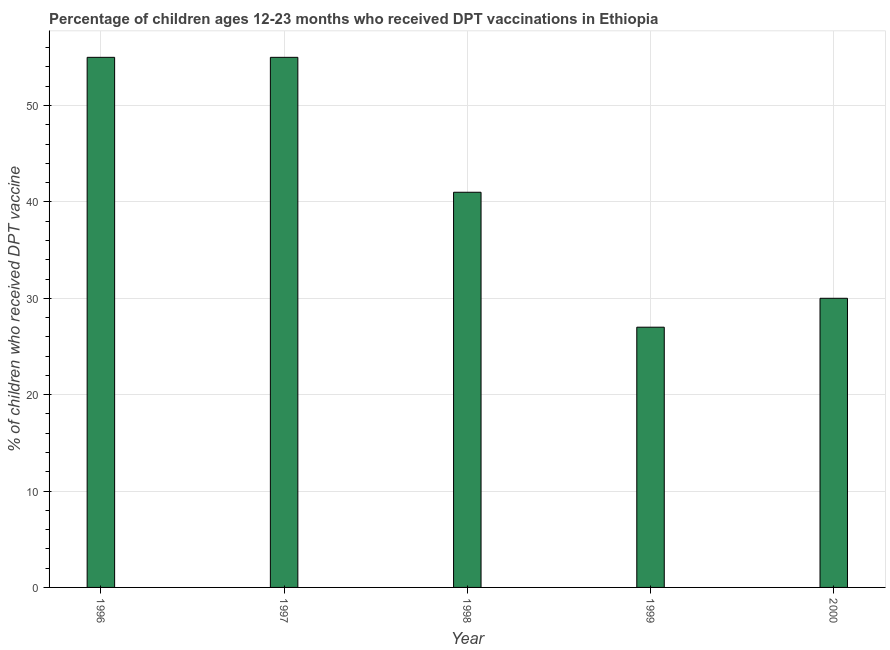Does the graph contain grids?
Keep it short and to the point. Yes. What is the title of the graph?
Provide a short and direct response. Percentage of children ages 12-23 months who received DPT vaccinations in Ethiopia. What is the label or title of the X-axis?
Give a very brief answer. Year. What is the label or title of the Y-axis?
Offer a terse response. % of children who received DPT vaccine. What is the percentage of children who received dpt vaccine in 1996?
Provide a short and direct response. 55. In which year was the percentage of children who received dpt vaccine maximum?
Offer a terse response. 1996. What is the sum of the percentage of children who received dpt vaccine?
Your answer should be very brief. 208. What is the average percentage of children who received dpt vaccine per year?
Keep it short and to the point. 41. What is the median percentage of children who received dpt vaccine?
Make the answer very short. 41. What is the ratio of the percentage of children who received dpt vaccine in 1998 to that in 2000?
Your response must be concise. 1.37. Is the percentage of children who received dpt vaccine in 1998 less than that in 1999?
Your answer should be compact. No. Is the sum of the percentage of children who received dpt vaccine in 1998 and 1999 greater than the maximum percentage of children who received dpt vaccine across all years?
Ensure brevity in your answer.  Yes. What is the difference between the highest and the lowest percentage of children who received dpt vaccine?
Your answer should be very brief. 28. In how many years, is the percentage of children who received dpt vaccine greater than the average percentage of children who received dpt vaccine taken over all years?
Keep it short and to the point. 2. How many bars are there?
Your response must be concise. 5. What is the % of children who received DPT vaccine in 1999?
Make the answer very short. 27. What is the % of children who received DPT vaccine in 2000?
Your response must be concise. 30. What is the difference between the % of children who received DPT vaccine in 1996 and 1999?
Ensure brevity in your answer.  28. What is the difference between the % of children who received DPT vaccine in 1997 and 1998?
Keep it short and to the point. 14. What is the difference between the % of children who received DPT vaccine in 1997 and 2000?
Your answer should be compact. 25. What is the ratio of the % of children who received DPT vaccine in 1996 to that in 1998?
Your answer should be compact. 1.34. What is the ratio of the % of children who received DPT vaccine in 1996 to that in 1999?
Your answer should be compact. 2.04. What is the ratio of the % of children who received DPT vaccine in 1996 to that in 2000?
Your answer should be compact. 1.83. What is the ratio of the % of children who received DPT vaccine in 1997 to that in 1998?
Ensure brevity in your answer.  1.34. What is the ratio of the % of children who received DPT vaccine in 1997 to that in 1999?
Your response must be concise. 2.04. What is the ratio of the % of children who received DPT vaccine in 1997 to that in 2000?
Make the answer very short. 1.83. What is the ratio of the % of children who received DPT vaccine in 1998 to that in 1999?
Your response must be concise. 1.52. What is the ratio of the % of children who received DPT vaccine in 1998 to that in 2000?
Your answer should be very brief. 1.37. What is the ratio of the % of children who received DPT vaccine in 1999 to that in 2000?
Ensure brevity in your answer.  0.9. 